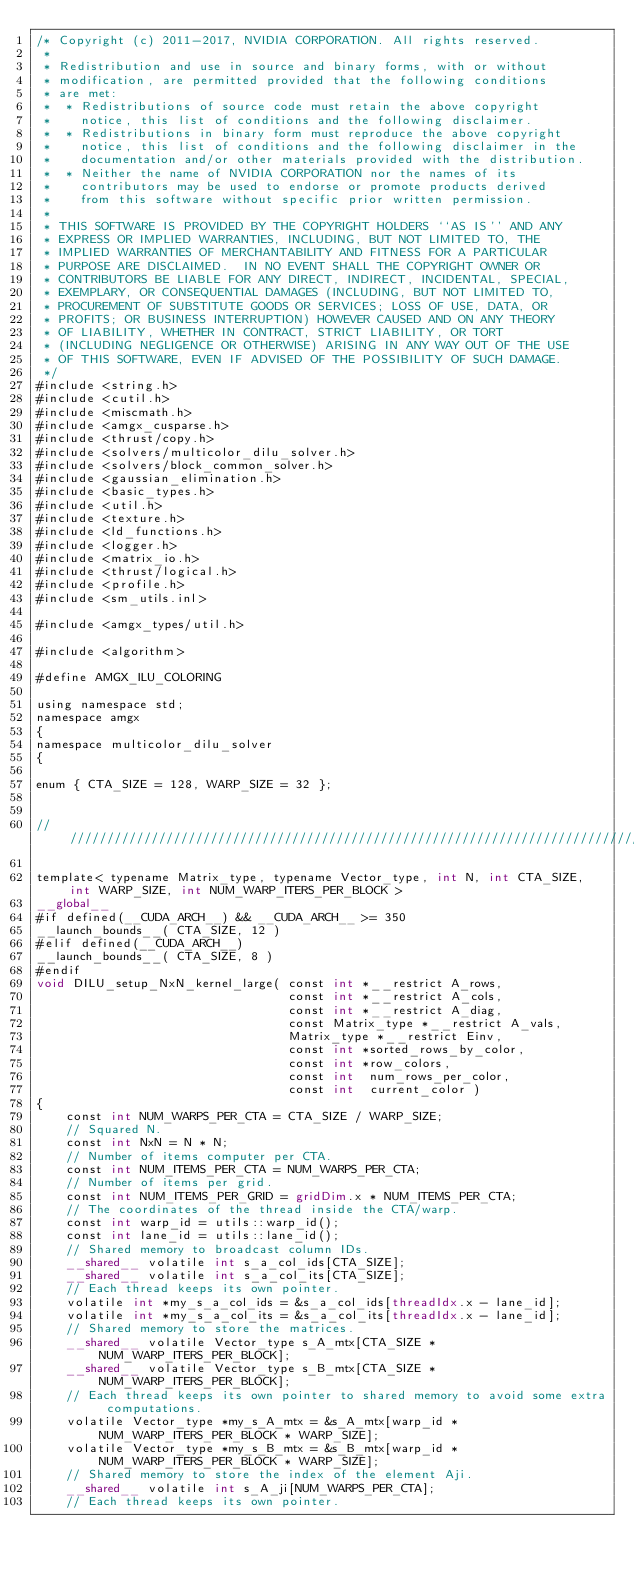Convert code to text. <code><loc_0><loc_0><loc_500><loc_500><_Cuda_>/* Copyright (c) 2011-2017, NVIDIA CORPORATION. All rights reserved.
 *
 * Redistribution and use in source and binary forms, with or without
 * modification, are permitted provided that the following conditions
 * are met:
 *  * Redistributions of source code must retain the above copyright
 *    notice, this list of conditions and the following disclaimer.
 *  * Redistributions in binary form must reproduce the above copyright
 *    notice, this list of conditions and the following disclaimer in the
 *    documentation and/or other materials provided with the distribution.
 *  * Neither the name of NVIDIA CORPORATION nor the names of its
 *    contributors may be used to endorse or promote products derived
 *    from this software without specific prior written permission.
 *
 * THIS SOFTWARE IS PROVIDED BY THE COPYRIGHT HOLDERS ``AS IS'' AND ANY
 * EXPRESS OR IMPLIED WARRANTIES, INCLUDING, BUT NOT LIMITED TO, THE
 * IMPLIED WARRANTIES OF MERCHANTABILITY AND FITNESS FOR A PARTICULAR
 * PURPOSE ARE DISCLAIMED.  IN NO EVENT SHALL THE COPYRIGHT OWNER OR
 * CONTRIBUTORS BE LIABLE FOR ANY DIRECT, INDIRECT, INCIDENTAL, SPECIAL,
 * EXEMPLARY, OR CONSEQUENTIAL DAMAGES (INCLUDING, BUT NOT LIMITED TO,
 * PROCUREMENT OF SUBSTITUTE GOODS OR SERVICES; LOSS OF USE, DATA, OR
 * PROFITS; OR BUSINESS INTERRUPTION) HOWEVER CAUSED AND ON ANY THEORY
 * OF LIABILITY, WHETHER IN CONTRACT, STRICT LIABILITY, OR TORT
 * (INCLUDING NEGLIGENCE OR OTHERWISE) ARISING IN ANY WAY OUT OF THE USE
 * OF THIS SOFTWARE, EVEN IF ADVISED OF THE POSSIBILITY OF SUCH DAMAGE.
 */
#include <string.h>
#include <cutil.h>
#include <miscmath.h>
#include <amgx_cusparse.h>
#include <thrust/copy.h>
#include <solvers/multicolor_dilu_solver.h>
#include <solvers/block_common_solver.h>
#include <gaussian_elimination.h>
#include <basic_types.h>
#include <util.h>
#include <texture.h>
#include <ld_functions.h>
#include <logger.h>
#include <matrix_io.h>
#include <thrust/logical.h>
#include <profile.h>
#include <sm_utils.inl>

#include <amgx_types/util.h>

#include <algorithm>

#define AMGX_ILU_COLORING

using namespace std;
namespace amgx
{
namespace multicolor_dilu_solver
{

enum { CTA_SIZE = 128, WARP_SIZE = 32 };


///////////////////////////////////////////////////////////////////////////////////////////////////////////////////////

template< typename Matrix_type, typename Vector_type, int N, int CTA_SIZE, int WARP_SIZE, int NUM_WARP_ITERS_PER_BLOCK >
__global__
#if defined(__CUDA_ARCH__) && __CUDA_ARCH__ >= 350
__launch_bounds__( CTA_SIZE, 12 )
#elif defined(__CUDA_ARCH__)
__launch_bounds__( CTA_SIZE, 8 )
#endif
void DILU_setup_NxN_kernel_large( const int *__restrict A_rows,
                                  const int *__restrict A_cols,
                                  const int *__restrict A_diag,
                                  const Matrix_type *__restrict A_vals,
                                  Matrix_type *__restrict Einv,
                                  const int *sorted_rows_by_color,
                                  const int *row_colors,
                                  const int  num_rows_per_color,
                                  const int  current_color )
{
    const int NUM_WARPS_PER_CTA = CTA_SIZE / WARP_SIZE;
    // Squared N.
    const int NxN = N * N;
    // Number of items computer per CTA.
    const int NUM_ITEMS_PER_CTA = NUM_WARPS_PER_CTA;
    // Number of items per grid.
    const int NUM_ITEMS_PER_GRID = gridDim.x * NUM_ITEMS_PER_CTA;
    // The coordinates of the thread inside the CTA/warp.
    const int warp_id = utils::warp_id();
    const int lane_id = utils::lane_id();
    // Shared memory to broadcast column IDs.
    __shared__ volatile int s_a_col_ids[CTA_SIZE];
    __shared__ volatile int s_a_col_its[CTA_SIZE];
    // Each thread keeps its own pointer.
    volatile int *my_s_a_col_ids = &s_a_col_ids[threadIdx.x - lane_id];
    volatile int *my_s_a_col_its = &s_a_col_its[threadIdx.x - lane_id];
    // Shared memory to store the matrices.
    __shared__ volatile Vector_type s_A_mtx[CTA_SIZE * NUM_WARP_ITERS_PER_BLOCK];
    __shared__ volatile Vector_type s_B_mtx[CTA_SIZE * NUM_WARP_ITERS_PER_BLOCK];
    // Each thread keeps its own pointer to shared memory to avoid some extra computations.
    volatile Vector_type *my_s_A_mtx = &s_A_mtx[warp_id * NUM_WARP_ITERS_PER_BLOCK * WARP_SIZE];
    volatile Vector_type *my_s_B_mtx = &s_B_mtx[warp_id * NUM_WARP_ITERS_PER_BLOCK * WARP_SIZE];
    // Shared memory to store the index of the element Aji.
    __shared__ volatile int s_A_ji[NUM_WARPS_PER_CTA];
    // Each thread keeps its own pointer.</code> 